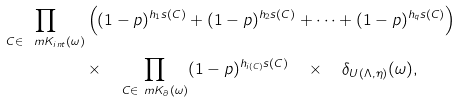Convert formula to latex. <formula><loc_0><loc_0><loc_500><loc_500>\prod _ { C \in \ m K _ { i n t } ( \omega ) } & \left ( ( 1 - p ) ^ { h _ { 1 } s ( C ) } + ( 1 - p ) ^ { h _ { 2 } s ( C ) } + \dots + ( 1 - p ) ^ { h _ { q } s ( C ) } \right ) \\ & \times \quad \prod _ { C \in \ m K _ { \partial } ( \omega ) } ( 1 - p ) ^ { h _ { i ( C ) } s ( C ) } \quad \times \quad \delta _ { U ( \Lambda , \eta ) } ( \omega ) ,</formula> 